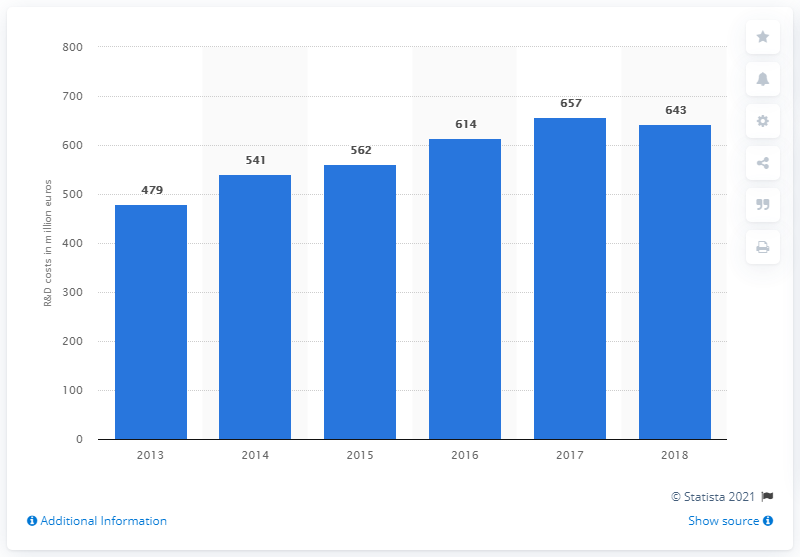Can you identify the year with the lowest R&D investment, and might this have an impact on the products released that year? As seen in the graph, 2013 was the year with the lowest R&D investment, with Ferrari spending 479 million euros. This reduced investment could potentially lead to fewer technological advancements in the products released during that period. However, the impact on Ferrari's product lineup would also depend on the length of their development cycles and whether innovations from previous years were being implemented. 